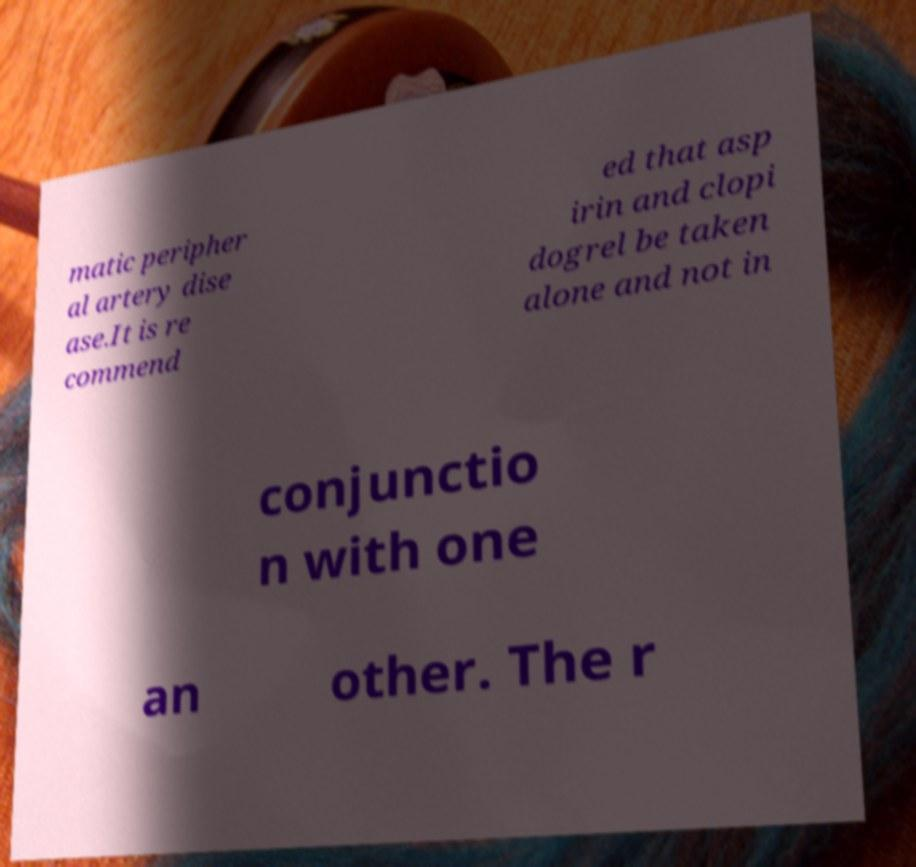Please read and relay the text visible in this image. What does it say? matic peripher al artery dise ase.It is re commend ed that asp irin and clopi dogrel be taken alone and not in conjunctio n with one an other. The r 